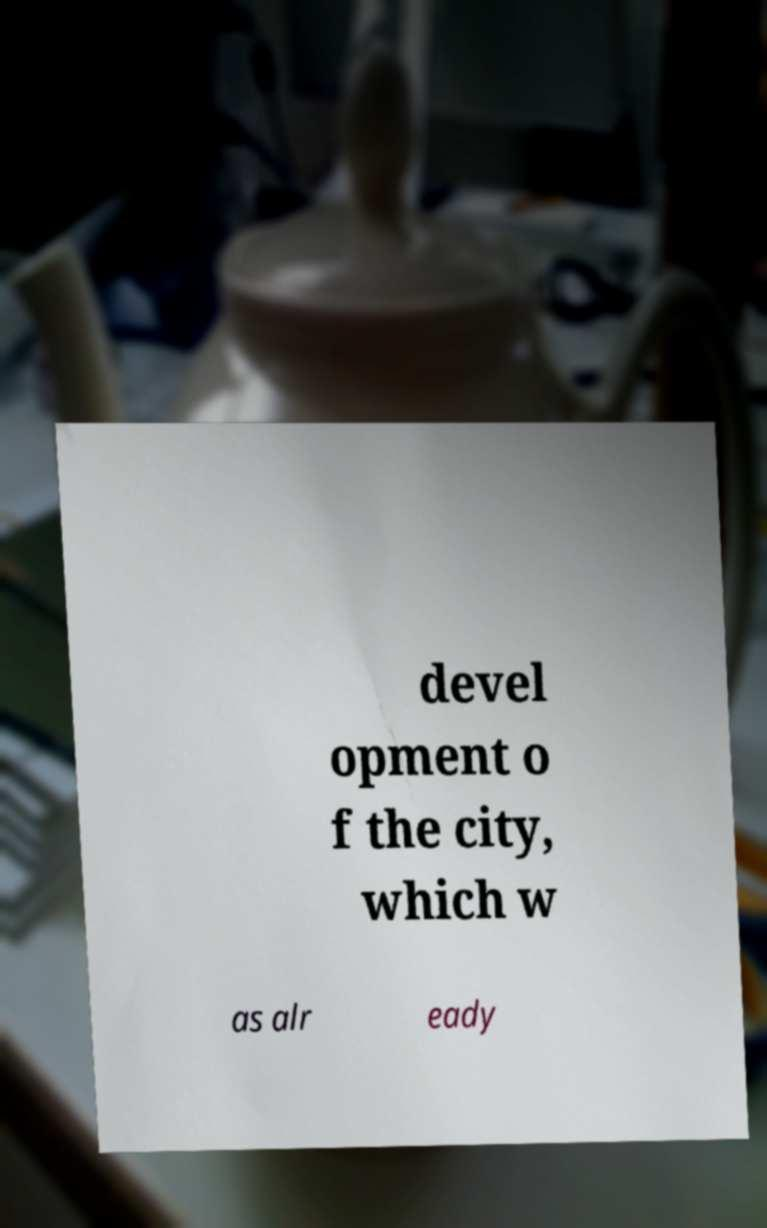There's text embedded in this image that I need extracted. Can you transcribe it verbatim? devel opment o f the city, which w as alr eady 